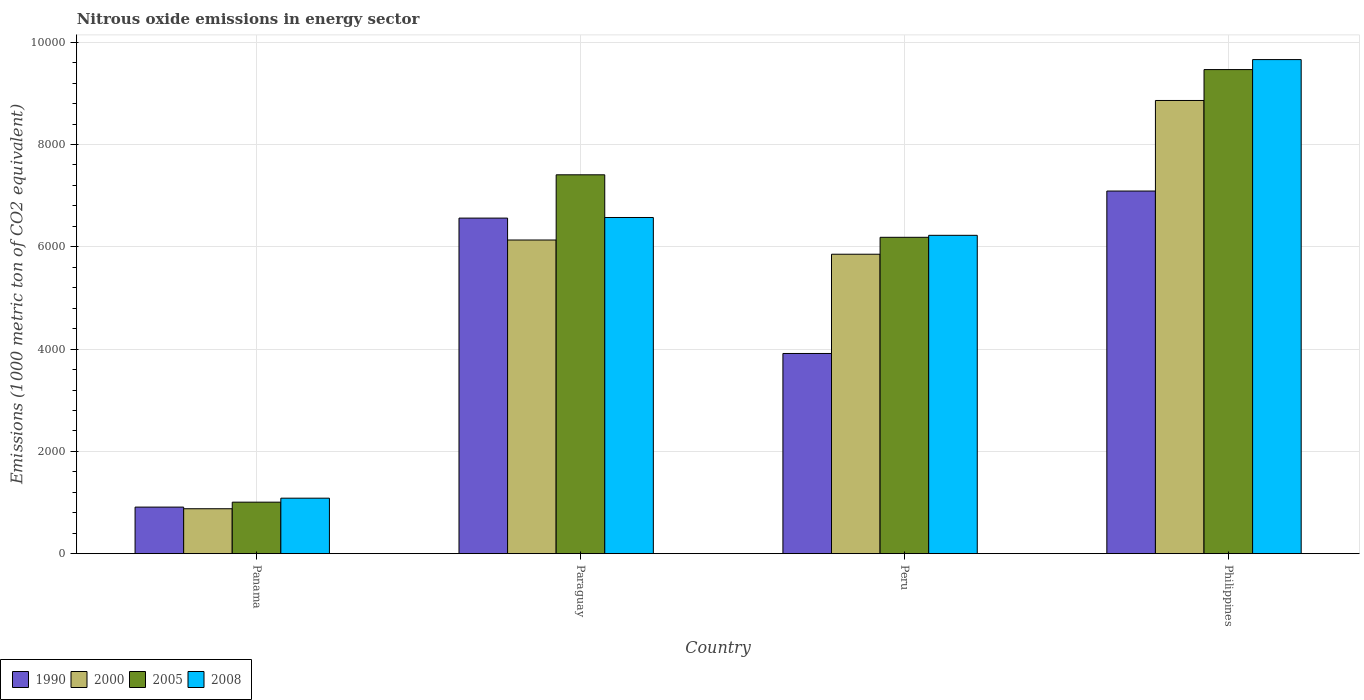How many different coloured bars are there?
Make the answer very short. 4. Are the number of bars on each tick of the X-axis equal?
Give a very brief answer. Yes. How many bars are there on the 2nd tick from the left?
Keep it short and to the point. 4. How many bars are there on the 2nd tick from the right?
Your answer should be compact. 4. What is the label of the 3rd group of bars from the left?
Your answer should be very brief. Peru. What is the amount of nitrous oxide emitted in 2008 in Peru?
Provide a short and direct response. 6224.5. Across all countries, what is the maximum amount of nitrous oxide emitted in 2005?
Give a very brief answer. 9465.1. Across all countries, what is the minimum amount of nitrous oxide emitted in 2000?
Your answer should be compact. 878.4. In which country was the amount of nitrous oxide emitted in 2008 maximum?
Your answer should be very brief. Philippines. In which country was the amount of nitrous oxide emitted in 2000 minimum?
Provide a succinct answer. Panama. What is the total amount of nitrous oxide emitted in 2000 in the graph?
Ensure brevity in your answer.  2.17e+04. What is the difference between the amount of nitrous oxide emitted in 2000 in Panama and that in Philippines?
Offer a terse response. -7982.7. What is the difference between the amount of nitrous oxide emitted in 2005 in Paraguay and the amount of nitrous oxide emitted in 2008 in Philippines?
Keep it short and to the point. -2253.1. What is the average amount of nitrous oxide emitted in 2000 per country?
Ensure brevity in your answer.  5431.8. What is the difference between the amount of nitrous oxide emitted of/in 2000 and amount of nitrous oxide emitted of/in 2005 in Panama?
Offer a terse response. -128.4. What is the ratio of the amount of nitrous oxide emitted in 2008 in Panama to that in Peru?
Offer a terse response. 0.17. Is the amount of nitrous oxide emitted in 2005 in Paraguay less than that in Peru?
Offer a terse response. No. What is the difference between the highest and the second highest amount of nitrous oxide emitted in 2000?
Give a very brief answer. -2728.3. What is the difference between the highest and the lowest amount of nitrous oxide emitted in 2008?
Provide a short and direct response. 8575.9. What does the 1st bar from the left in Peru represents?
Your response must be concise. 1990. What does the 3rd bar from the right in Philippines represents?
Keep it short and to the point. 2000. Is it the case that in every country, the sum of the amount of nitrous oxide emitted in 1990 and amount of nitrous oxide emitted in 2005 is greater than the amount of nitrous oxide emitted in 2008?
Your answer should be compact. Yes. Are all the bars in the graph horizontal?
Ensure brevity in your answer.  No. How many countries are there in the graph?
Ensure brevity in your answer.  4. Are the values on the major ticks of Y-axis written in scientific E-notation?
Offer a terse response. No. Does the graph contain any zero values?
Ensure brevity in your answer.  No. How many legend labels are there?
Offer a terse response. 4. How are the legend labels stacked?
Make the answer very short. Horizontal. What is the title of the graph?
Offer a very short reply. Nitrous oxide emissions in energy sector. What is the label or title of the Y-axis?
Your answer should be very brief. Emissions (1000 metric ton of CO2 equivalent). What is the Emissions (1000 metric ton of CO2 equivalent) in 1990 in Panama?
Your answer should be very brief. 910.4. What is the Emissions (1000 metric ton of CO2 equivalent) in 2000 in Panama?
Provide a short and direct response. 878.4. What is the Emissions (1000 metric ton of CO2 equivalent) of 2005 in Panama?
Provide a short and direct response. 1006.8. What is the Emissions (1000 metric ton of CO2 equivalent) in 2008 in Panama?
Give a very brief answer. 1084.9. What is the Emissions (1000 metric ton of CO2 equivalent) of 1990 in Paraguay?
Offer a terse response. 6561.2. What is the Emissions (1000 metric ton of CO2 equivalent) of 2000 in Paraguay?
Ensure brevity in your answer.  6132.8. What is the Emissions (1000 metric ton of CO2 equivalent) of 2005 in Paraguay?
Your response must be concise. 7407.7. What is the Emissions (1000 metric ton of CO2 equivalent) of 2008 in Paraguay?
Your answer should be very brief. 6573. What is the Emissions (1000 metric ton of CO2 equivalent) of 1990 in Peru?
Provide a short and direct response. 3914.1. What is the Emissions (1000 metric ton of CO2 equivalent) of 2000 in Peru?
Your response must be concise. 5854.9. What is the Emissions (1000 metric ton of CO2 equivalent) of 2005 in Peru?
Ensure brevity in your answer.  6185.8. What is the Emissions (1000 metric ton of CO2 equivalent) of 2008 in Peru?
Your response must be concise. 6224.5. What is the Emissions (1000 metric ton of CO2 equivalent) of 1990 in Philippines?
Offer a very short reply. 7090.2. What is the Emissions (1000 metric ton of CO2 equivalent) of 2000 in Philippines?
Provide a succinct answer. 8861.1. What is the Emissions (1000 metric ton of CO2 equivalent) in 2005 in Philippines?
Provide a short and direct response. 9465.1. What is the Emissions (1000 metric ton of CO2 equivalent) in 2008 in Philippines?
Offer a terse response. 9660.8. Across all countries, what is the maximum Emissions (1000 metric ton of CO2 equivalent) of 1990?
Ensure brevity in your answer.  7090.2. Across all countries, what is the maximum Emissions (1000 metric ton of CO2 equivalent) of 2000?
Keep it short and to the point. 8861.1. Across all countries, what is the maximum Emissions (1000 metric ton of CO2 equivalent) in 2005?
Provide a succinct answer. 9465.1. Across all countries, what is the maximum Emissions (1000 metric ton of CO2 equivalent) of 2008?
Give a very brief answer. 9660.8. Across all countries, what is the minimum Emissions (1000 metric ton of CO2 equivalent) in 1990?
Ensure brevity in your answer.  910.4. Across all countries, what is the minimum Emissions (1000 metric ton of CO2 equivalent) of 2000?
Your answer should be very brief. 878.4. Across all countries, what is the minimum Emissions (1000 metric ton of CO2 equivalent) in 2005?
Your response must be concise. 1006.8. Across all countries, what is the minimum Emissions (1000 metric ton of CO2 equivalent) of 2008?
Your answer should be very brief. 1084.9. What is the total Emissions (1000 metric ton of CO2 equivalent) in 1990 in the graph?
Provide a short and direct response. 1.85e+04. What is the total Emissions (1000 metric ton of CO2 equivalent) in 2000 in the graph?
Your response must be concise. 2.17e+04. What is the total Emissions (1000 metric ton of CO2 equivalent) of 2005 in the graph?
Offer a terse response. 2.41e+04. What is the total Emissions (1000 metric ton of CO2 equivalent) in 2008 in the graph?
Offer a very short reply. 2.35e+04. What is the difference between the Emissions (1000 metric ton of CO2 equivalent) in 1990 in Panama and that in Paraguay?
Ensure brevity in your answer.  -5650.8. What is the difference between the Emissions (1000 metric ton of CO2 equivalent) of 2000 in Panama and that in Paraguay?
Ensure brevity in your answer.  -5254.4. What is the difference between the Emissions (1000 metric ton of CO2 equivalent) in 2005 in Panama and that in Paraguay?
Your answer should be very brief. -6400.9. What is the difference between the Emissions (1000 metric ton of CO2 equivalent) in 2008 in Panama and that in Paraguay?
Ensure brevity in your answer.  -5488.1. What is the difference between the Emissions (1000 metric ton of CO2 equivalent) of 1990 in Panama and that in Peru?
Your response must be concise. -3003.7. What is the difference between the Emissions (1000 metric ton of CO2 equivalent) of 2000 in Panama and that in Peru?
Provide a short and direct response. -4976.5. What is the difference between the Emissions (1000 metric ton of CO2 equivalent) of 2005 in Panama and that in Peru?
Your answer should be compact. -5179. What is the difference between the Emissions (1000 metric ton of CO2 equivalent) of 2008 in Panama and that in Peru?
Your answer should be very brief. -5139.6. What is the difference between the Emissions (1000 metric ton of CO2 equivalent) of 1990 in Panama and that in Philippines?
Offer a very short reply. -6179.8. What is the difference between the Emissions (1000 metric ton of CO2 equivalent) of 2000 in Panama and that in Philippines?
Your response must be concise. -7982.7. What is the difference between the Emissions (1000 metric ton of CO2 equivalent) of 2005 in Panama and that in Philippines?
Your answer should be compact. -8458.3. What is the difference between the Emissions (1000 metric ton of CO2 equivalent) of 2008 in Panama and that in Philippines?
Make the answer very short. -8575.9. What is the difference between the Emissions (1000 metric ton of CO2 equivalent) in 1990 in Paraguay and that in Peru?
Keep it short and to the point. 2647.1. What is the difference between the Emissions (1000 metric ton of CO2 equivalent) in 2000 in Paraguay and that in Peru?
Provide a succinct answer. 277.9. What is the difference between the Emissions (1000 metric ton of CO2 equivalent) in 2005 in Paraguay and that in Peru?
Your response must be concise. 1221.9. What is the difference between the Emissions (1000 metric ton of CO2 equivalent) of 2008 in Paraguay and that in Peru?
Keep it short and to the point. 348.5. What is the difference between the Emissions (1000 metric ton of CO2 equivalent) of 1990 in Paraguay and that in Philippines?
Give a very brief answer. -529. What is the difference between the Emissions (1000 metric ton of CO2 equivalent) in 2000 in Paraguay and that in Philippines?
Keep it short and to the point. -2728.3. What is the difference between the Emissions (1000 metric ton of CO2 equivalent) in 2005 in Paraguay and that in Philippines?
Ensure brevity in your answer.  -2057.4. What is the difference between the Emissions (1000 metric ton of CO2 equivalent) in 2008 in Paraguay and that in Philippines?
Offer a very short reply. -3087.8. What is the difference between the Emissions (1000 metric ton of CO2 equivalent) in 1990 in Peru and that in Philippines?
Make the answer very short. -3176.1. What is the difference between the Emissions (1000 metric ton of CO2 equivalent) in 2000 in Peru and that in Philippines?
Keep it short and to the point. -3006.2. What is the difference between the Emissions (1000 metric ton of CO2 equivalent) of 2005 in Peru and that in Philippines?
Provide a succinct answer. -3279.3. What is the difference between the Emissions (1000 metric ton of CO2 equivalent) in 2008 in Peru and that in Philippines?
Offer a very short reply. -3436.3. What is the difference between the Emissions (1000 metric ton of CO2 equivalent) of 1990 in Panama and the Emissions (1000 metric ton of CO2 equivalent) of 2000 in Paraguay?
Offer a very short reply. -5222.4. What is the difference between the Emissions (1000 metric ton of CO2 equivalent) in 1990 in Panama and the Emissions (1000 metric ton of CO2 equivalent) in 2005 in Paraguay?
Give a very brief answer. -6497.3. What is the difference between the Emissions (1000 metric ton of CO2 equivalent) of 1990 in Panama and the Emissions (1000 metric ton of CO2 equivalent) of 2008 in Paraguay?
Your response must be concise. -5662.6. What is the difference between the Emissions (1000 metric ton of CO2 equivalent) in 2000 in Panama and the Emissions (1000 metric ton of CO2 equivalent) in 2005 in Paraguay?
Make the answer very short. -6529.3. What is the difference between the Emissions (1000 metric ton of CO2 equivalent) of 2000 in Panama and the Emissions (1000 metric ton of CO2 equivalent) of 2008 in Paraguay?
Make the answer very short. -5694.6. What is the difference between the Emissions (1000 metric ton of CO2 equivalent) of 2005 in Panama and the Emissions (1000 metric ton of CO2 equivalent) of 2008 in Paraguay?
Provide a short and direct response. -5566.2. What is the difference between the Emissions (1000 metric ton of CO2 equivalent) in 1990 in Panama and the Emissions (1000 metric ton of CO2 equivalent) in 2000 in Peru?
Give a very brief answer. -4944.5. What is the difference between the Emissions (1000 metric ton of CO2 equivalent) in 1990 in Panama and the Emissions (1000 metric ton of CO2 equivalent) in 2005 in Peru?
Ensure brevity in your answer.  -5275.4. What is the difference between the Emissions (1000 metric ton of CO2 equivalent) in 1990 in Panama and the Emissions (1000 metric ton of CO2 equivalent) in 2008 in Peru?
Give a very brief answer. -5314.1. What is the difference between the Emissions (1000 metric ton of CO2 equivalent) of 2000 in Panama and the Emissions (1000 metric ton of CO2 equivalent) of 2005 in Peru?
Your response must be concise. -5307.4. What is the difference between the Emissions (1000 metric ton of CO2 equivalent) of 2000 in Panama and the Emissions (1000 metric ton of CO2 equivalent) of 2008 in Peru?
Offer a terse response. -5346.1. What is the difference between the Emissions (1000 metric ton of CO2 equivalent) in 2005 in Panama and the Emissions (1000 metric ton of CO2 equivalent) in 2008 in Peru?
Offer a very short reply. -5217.7. What is the difference between the Emissions (1000 metric ton of CO2 equivalent) in 1990 in Panama and the Emissions (1000 metric ton of CO2 equivalent) in 2000 in Philippines?
Your answer should be very brief. -7950.7. What is the difference between the Emissions (1000 metric ton of CO2 equivalent) of 1990 in Panama and the Emissions (1000 metric ton of CO2 equivalent) of 2005 in Philippines?
Provide a succinct answer. -8554.7. What is the difference between the Emissions (1000 metric ton of CO2 equivalent) of 1990 in Panama and the Emissions (1000 metric ton of CO2 equivalent) of 2008 in Philippines?
Keep it short and to the point. -8750.4. What is the difference between the Emissions (1000 metric ton of CO2 equivalent) in 2000 in Panama and the Emissions (1000 metric ton of CO2 equivalent) in 2005 in Philippines?
Offer a terse response. -8586.7. What is the difference between the Emissions (1000 metric ton of CO2 equivalent) in 2000 in Panama and the Emissions (1000 metric ton of CO2 equivalent) in 2008 in Philippines?
Make the answer very short. -8782.4. What is the difference between the Emissions (1000 metric ton of CO2 equivalent) in 2005 in Panama and the Emissions (1000 metric ton of CO2 equivalent) in 2008 in Philippines?
Offer a terse response. -8654. What is the difference between the Emissions (1000 metric ton of CO2 equivalent) of 1990 in Paraguay and the Emissions (1000 metric ton of CO2 equivalent) of 2000 in Peru?
Ensure brevity in your answer.  706.3. What is the difference between the Emissions (1000 metric ton of CO2 equivalent) in 1990 in Paraguay and the Emissions (1000 metric ton of CO2 equivalent) in 2005 in Peru?
Provide a short and direct response. 375.4. What is the difference between the Emissions (1000 metric ton of CO2 equivalent) of 1990 in Paraguay and the Emissions (1000 metric ton of CO2 equivalent) of 2008 in Peru?
Your answer should be compact. 336.7. What is the difference between the Emissions (1000 metric ton of CO2 equivalent) of 2000 in Paraguay and the Emissions (1000 metric ton of CO2 equivalent) of 2005 in Peru?
Offer a very short reply. -53. What is the difference between the Emissions (1000 metric ton of CO2 equivalent) of 2000 in Paraguay and the Emissions (1000 metric ton of CO2 equivalent) of 2008 in Peru?
Provide a short and direct response. -91.7. What is the difference between the Emissions (1000 metric ton of CO2 equivalent) in 2005 in Paraguay and the Emissions (1000 metric ton of CO2 equivalent) in 2008 in Peru?
Offer a very short reply. 1183.2. What is the difference between the Emissions (1000 metric ton of CO2 equivalent) of 1990 in Paraguay and the Emissions (1000 metric ton of CO2 equivalent) of 2000 in Philippines?
Keep it short and to the point. -2299.9. What is the difference between the Emissions (1000 metric ton of CO2 equivalent) of 1990 in Paraguay and the Emissions (1000 metric ton of CO2 equivalent) of 2005 in Philippines?
Give a very brief answer. -2903.9. What is the difference between the Emissions (1000 metric ton of CO2 equivalent) in 1990 in Paraguay and the Emissions (1000 metric ton of CO2 equivalent) in 2008 in Philippines?
Your answer should be very brief. -3099.6. What is the difference between the Emissions (1000 metric ton of CO2 equivalent) of 2000 in Paraguay and the Emissions (1000 metric ton of CO2 equivalent) of 2005 in Philippines?
Give a very brief answer. -3332.3. What is the difference between the Emissions (1000 metric ton of CO2 equivalent) in 2000 in Paraguay and the Emissions (1000 metric ton of CO2 equivalent) in 2008 in Philippines?
Make the answer very short. -3528. What is the difference between the Emissions (1000 metric ton of CO2 equivalent) in 2005 in Paraguay and the Emissions (1000 metric ton of CO2 equivalent) in 2008 in Philippines?
Offer a very short reply. -2253.1. What is the difference between the Emissions (1000 metric ton of CO2 equivalent) of 1990 in Peru and the Emissions (1000 metric ton of CO2 equivalent) of 2000 in Philippines?
Keep it short and to the point. -4947. What is the difference between the Emissions (1000 metric ton of CO2 equivalent) in 1990 in Peru and the Emissions (1000 metric ton of CO2 equivalent) in 2005 in Philippines?
Your answer should be compact. -5551. What is the difference between the Emissions (1000 metric ton of CO2 equivalent) of 1990 in Peru and the Emissions (1000 metric ton of CO2 equivalent) of 2008 in Philippines?
Provide a short and direct response. -5746.7. What is the difference between the Emissions (1000 metric ton of CO2 equivalent) of 2000 in Peru and the Emissions (1000 metric ton of CO2 equivalent) of 2005 in Philippines?
Your answer should be compact. -3610.2. What is the difference between the Emissions (1000 metric ton of CO2 equivalent) of 2000 in Peru and the Emissions (1000 metric ton of CO2 equivalent) of 2008 in Philippines?
Provide a short and direct response. -3805.9. What is the difference between the Emissions (1000 metric ton of CO2 equivalent) in 2005 in Peru and the Emissions (1000 metric ton of CO2 equivalent) in 2008 in Philippines?
Your answer should be very brief. -3475. What is the average Emissions (1000 metric ton of CO2 equivalent) in 1990 per country?
Your answer should be very brief. 4618.98. What is the average Emissions (1000 metric ton of CO2 equivalent) in 2000 per country?
Offer a terse response. 5431.8. What is the average Emissions (1000 metric ton of CO2 equivalent) of 2005 per country?
Make the answer very short. 6016.35. What is the average Emissions (1000 metric ton of CO2 equivalent) in 2008 per country?
Give a very brief answer. 5885.8. What is the difference between the Emissions (1000 metric ton of CO2 equivalent) of 1990 and Emissions (1000 metric ton of CO2 equivalent) of 2005 in Panama?
Offer a terse response. -96.4. What is the difference between the Emissions (1000 metric ton of CO2 equivalent) in 1990 and Emissions (1000 metric ton of CO2 equivalent) in 2008 in Panama?
Give a very brief answer. -174.5. What is the difference between the Emissions (1000 metric ton of CO2 equivalent) in 2000 and Emissions (1000 metric ton of CO2 equivalent) in 2005 in Panama?
Provide a short and direct response. -128.4. What is the difference between the Emissions (1000 metric ton of CO2 equivalent) of 2000 and Emissions (1000 metric ton of CO2 equivalent) of 2008 in Panama?
Your answer should be very brief. -206.5. What is the difference between the Emissions (1000 metric ton of CO2 equivalent) in 2005 and Emissions (1000 metric ton of CO2 equivalent) in 2008 in Panama?
Provide a succinct answer. -78.1. What is the difference between the Emissions (1000 metric ton of CO2 equivalent) of 1990 and Emissions (1000 metric ton of CO2 equivalent) of 2000 in Paraguay?
Provide a short and direct response. 428.4. What is the difference between the Emissions (1000 metric ton of CO2 equivalent) of 1990 and Emissions (1000 metric ton of CO2 equivalent) of 2005 in Paraguay?
Keep it short and to the point. -846.5. What is the difference between the Emissions (1000 metric ton of CO2 equivalent) in 2000 and Emissions (1000 metric ton of CO2 equivalent) in 2005 in Paraguay?
Keep it short and to the point. -1274.9. What is the difference between the Emissions (1000 metric ton of CO2 equivalent) in 2000 and Emissions (1000 metric ton of CO2 equivalent) in 2008 in Paraguay?
Give a very brief answer. -440.2. What is the difference between the Emissions (1000 metric ton of CO2 equivalent) of 2005 and Emissions (1000 metric ton of CO2 equivalent) of 2008 in Paraguay?
Offer a terse response. 834.7. What is the difference between the Emissions (1000 metric ton of CO2 equivalent) of 1990 and Emissions (1000 metric ton of CO2 equivalent) of 2000 in Peru?
Offer a very short reply. -1940.8. What is the difference between the Emissions (1000 metric ton of CO2 equivalent) of 1990 and Emissions (1000 metric ton of CO2 equivalent) of 2005 in Peru?
Your response must be concise. -2271.7. What is the difference between the Emissions (1000 metric ton of CO2 equivalent) of 1990 and Emissions (1000 metric ton of CO2 equivalent) of 2008 in Peru?
Keep it short and to the point. -2310.4. What is the difference between the Emissions (1000 metric ton of CO2 equivalent) in 2000 and Emissions (1000 metric ton of CO2 equivalent) in 2005 in Peru?
Your answer should be compact. -330.9. What is the difference between the Emissions (1000 metric ton of CO2 equivalent) of 2000 and Emissions (1000 metric ton of CO2 equivalent) of 2008 in Peru?
Ensure brevity in your answer.  -369.6. What is the difference between the Emissions (1000 metric ton of CO2 equivalent) in 2005 and Emissions (1000 metric ton of CO2 equivalent) in 2008 in Peru?
Your answer should be compact. -38.7. What is the difference between the Emissions (1000 metric ton of CO2 equivalent) in 1990 and Emissions (1000 metric ton of CO2 equivalent) in 2000 in Philippines?
Provide a short and direct response. -1770.9. What is the difference between the Emissions (1000 metric ton of CO2 equivalent) of 1990 and Emissions (1000 metric ton of CO2 equivalent) of 2005 in Philippines?
Give a very brief answer. -2374.9. What is the difference between the Emissions (1000 metric ton of CO2 equivalent) in 1990 and Emissions (1000 metric ton of CO2 equivalent) in 2008 in Philippines?
Your answer should be very brief. -2570.6. What is the difference between the Emissions (1000 metric ton of CO2 equivalent) in 2000 and Emissions (1000 metric ton of CO2 equivalent) in 2005 in Philippines?
Give a very brief answer. -604. What is the difference between the Emissions (1000 metric ton of CO2 equivalent) of 2000 and Emissions (1000 metric ton of CO2 equivalent) of 2008 in Philippines?
Provide a short and direct response. -799.7. What is the difference between the Emissions (1000 metric ton of CO2 equivalent) of 2005 and Emissions (1000 metric ton of CO2 equivalent) of 2008 in Philippines?
Give a very brief answer. -195.7. What is the ratio of the Emissions (1000 metric ton of CO2 equivalent) in 1990 in Panama to that in Paraguay?
Give a very brief answer. 0.14. What is the ratio of the Emissions (1000 metric ton of CO2 equivalent) in 2000 in Panama to that in Paraguay?
Offer a very short reply. 0.14. What is the ratio of the Emissions (1000 metric ton of CO2 equivalent) in 2005 in Panama to that in Paraguay?
Give a very brief answer. 0.14. What is the ratio of the Emissions (1000 metric ton of CO2 equivalent) in 2008 in Panama to that in Paraguay?
Make the answer very short. 0.17. What is the ratio of the Emissions (1000 metric ton of CO2 equivalent) in 1990 in Panama to that in Peru?
Your answer should be compact. 0.23. What is the ratio of the Emissions (1000 metric ton of CO2 equivalent) in 2000 in Panama to that in Peru?
Your answer should be compact. 0.15. What is the ratio of the Emissions (1000 metric ton of CO2 equivalent) in 2005 in Panama to that in Peru?
Make the answer very short. 0.16. What is the ratio of the Emissions (1000 metric ton of CO2 equivalent) of 2008 in Panama to that in Peru?
Your answer should be compact. 0.17. What is the ratio of the Emissions (1000 metric ton of CO2 equivalent) of 1990 in Panama to that in Philippines?
Your answer should be compact. 0.13. What is the ratio of the Emissions (1000 metric ton of CO2 equivalent) of 2000 in Panama to that in Philippines?
Provide a succinct answer. 0.1. What is the ratio of the Emissions (1000 metric ton of CO2 equivalent) of 2005 in Panama to that in Philippines?
Your answer should be compact. 0.11. What is the ratio of the Emissions (1000 metric ton of CO2 equivalent) in 2008 in Panama to that in Philippines?
Offer a very short reply. 0.11. What is the ratio of the Emissions (1000 metric ton of CO2 equivalent) in 1990 in Paraguay to that in Peru?
Ensure brevity in your answer.  1.68. What is the ratio of the Emissions (1000 metric ton of CO2 equivalent) in 2000 in Paraguay to that in Peru?
Offer a terse response. 1.05. What is the ratio of the Emissions (1000 metric ton of CO2 equivalent) in 2005 in Paraguay to that in Peru?
Keep it short and to the point. 1.2. What is the ratio of the Emissions (1000 metric ton of CO2 equivalent) in 2008 in Paraguay to that in Peru?
Offer a very short reply. 1.06. What is the ratio of the Emissions (1000 metric ton of CO2 equivalent) of 1990 in Paraguay to that in Philippines?
Offer a very short reply. 0.93. What is the ratio of the Emissions (1000 metric ton of CO2 equivalent) in 2000 in Paraguay to that in Philippines?
Offer a terse response. 0.69. What is the ratio of the Emissions (1000 metric ton of CO2 equivalent) in 2005 in Paraguay to that in Philippines?
Your answer should be very brief. 0.78. What is the ratio of the Emissions (1000 metric ton of CO2 equivalent) of 2008 in Paraguay to that in Philippines?
Your response must be concise. 0.68. What is the ratio of the Emissions (1000 metric ton of CO2 equivalent) in 1990 in Peru to that in Philippines?
Your answer should be very brief. 0.55. What is the ratio of the Emissions (1000 metric ton of CO2 equivalent) of 2000 in Peru to that in Philippines?
Ensure brevity in your answer.  0.66. What is the ratio of the Emissions (1000 metric ton of CO2 equivalent) of 2005 in Peru to that in Philippines?
Offer a terse response. 0.65. What is the ratio of the Emissions (1000 metric ton of CO2 equivalent) of 2008 in Peru to that in Philippines?
Provide a short and direct response. 0.64. What is the difference between the highest and the second highest Emissions (1000 metric ton of CO2 equivalent) in 1990?
Ensure brevity in your answer.  529. What is the difference between the highest and the second highest Emissions (1000 metric ton of CO2 equivalent) in 2000?
Your response must be concise. 2728.3. What is the difference between the highest and the second highest Emissions (1000 metric ton of CO2 equivalent) of 2005?
Ensure brevity in your answer.  2057.4. What is the difference between the highest and the second highest Emissions (1000 metric ton of CO2 equivalent) in 2008?
Offer a terse response. 3087.8. What is the difference between the highest and the lowest Emissions (1000 metric ton of CO2 equivalent) in 1990?
Provide a short and direct response. 6179.8. What is the difference between the highest and the lowest Emissions (1000 metric ton of CO2 equivalent) of 2000?
Your answer should be very brief. 7982.7. What is the difference between the highest and the lowest Emissions (1000 metric ton of CO2 equivalent) in 2005?
Offer a very short reply. 8458.3. What is the difference between the highest and the lowest Emissions (1000 metric ton of CO2 equivalent) in 2008?
Ensure brevity in your answer.  8575.9. 